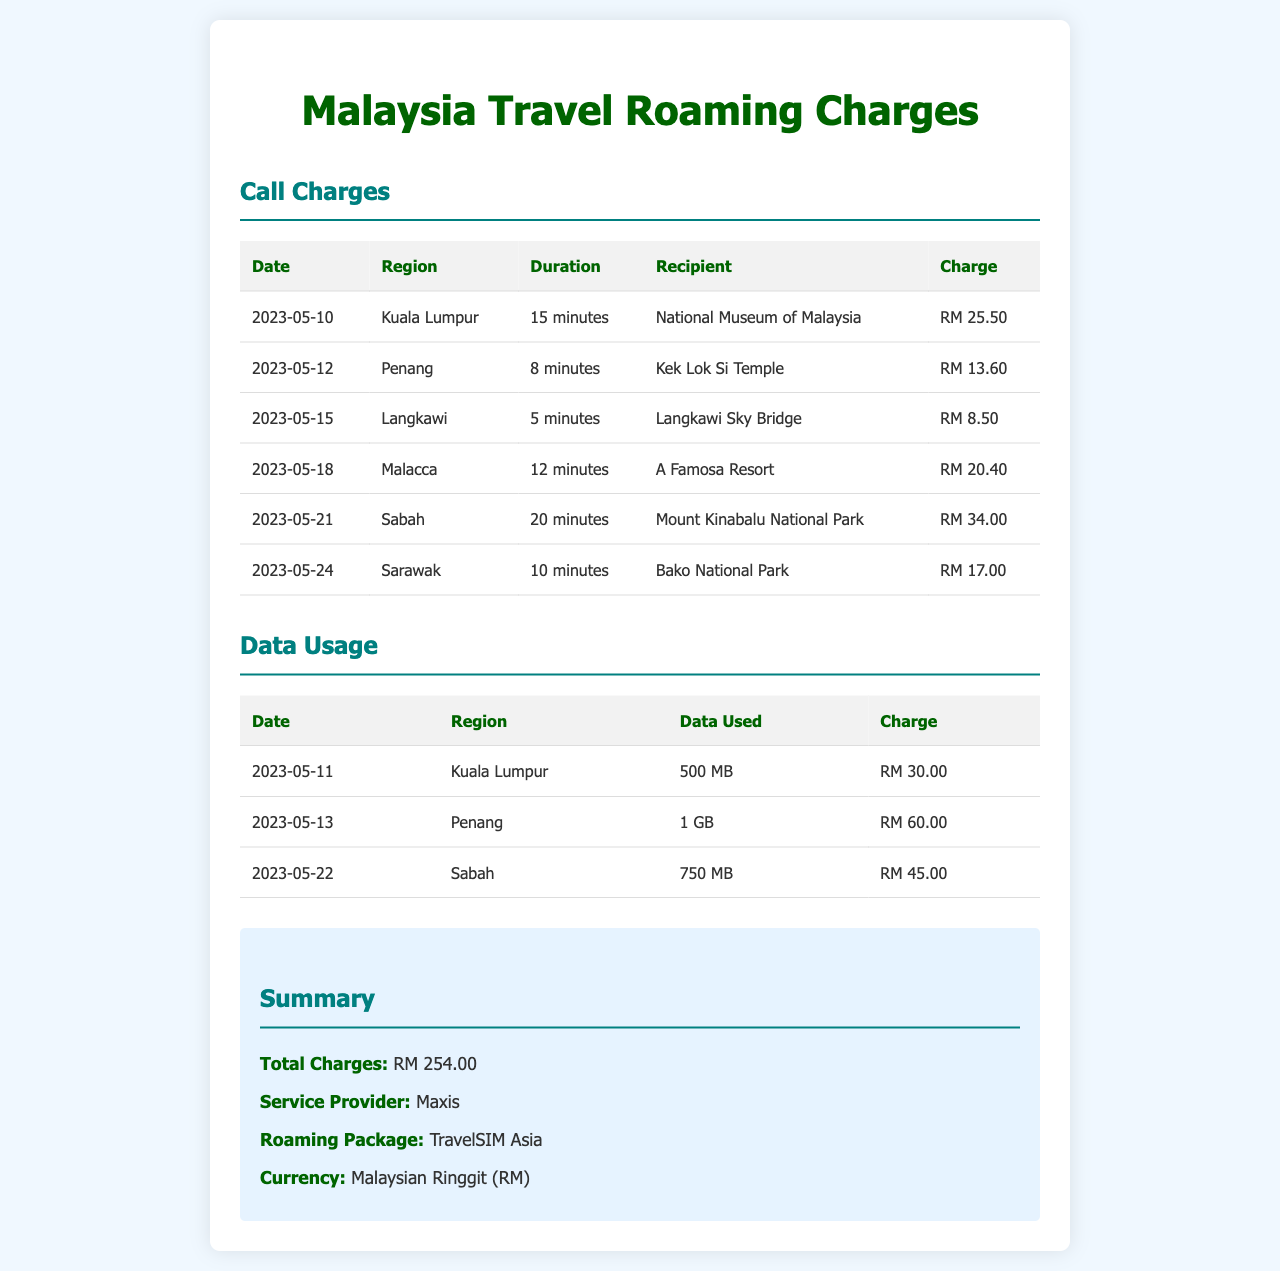What is the total charges incurred? The total charges are listed in the summary section of the document, which sums up all the call and data usage charges.
Answer: RM 254.00 Who is the service provider? The service provider is mentioned in the summary section, identifying the company responsible for the roaming charges.
Answer: Maxis What region incurred the highest call charge? By comparing the charges for each region listed in the call charges table, the region with the highest charge can be identified.
Answer: Sabah What was the duration of the call made in Malacca? The duration for the call made in Malacca can be found in the call charges table where the specific details for that region are provided.
Answer: 12 minutes How much data was used in Penang? The data used in Penang is specified in the data usage table, providing details of the volume used during the visit.
Answer: 1 GB What was the charge for data usage in Kuala Lumpur? The charge for data usage in Kuala Lumpur is found in the data usage table, indicating the cost associated with the data used.
Answer: RM 30.00 Which region had the lowest call charge? By examining the call charges table, the region with the lowest charge can be identified by comparing individual charges.
Answer: Langkawi How many minutes were spent on the call to the National Museum of Malaysia? The call duration to the National Museum of Malaysia can be found in the call charges table where this specific call detail is recorded.
Answer: 15 minutes What is the roaming package used? The roaming package is stated in the summary section of the document, identifying the specific plan utilized during travels.
Answer: TravelSIM Asia 